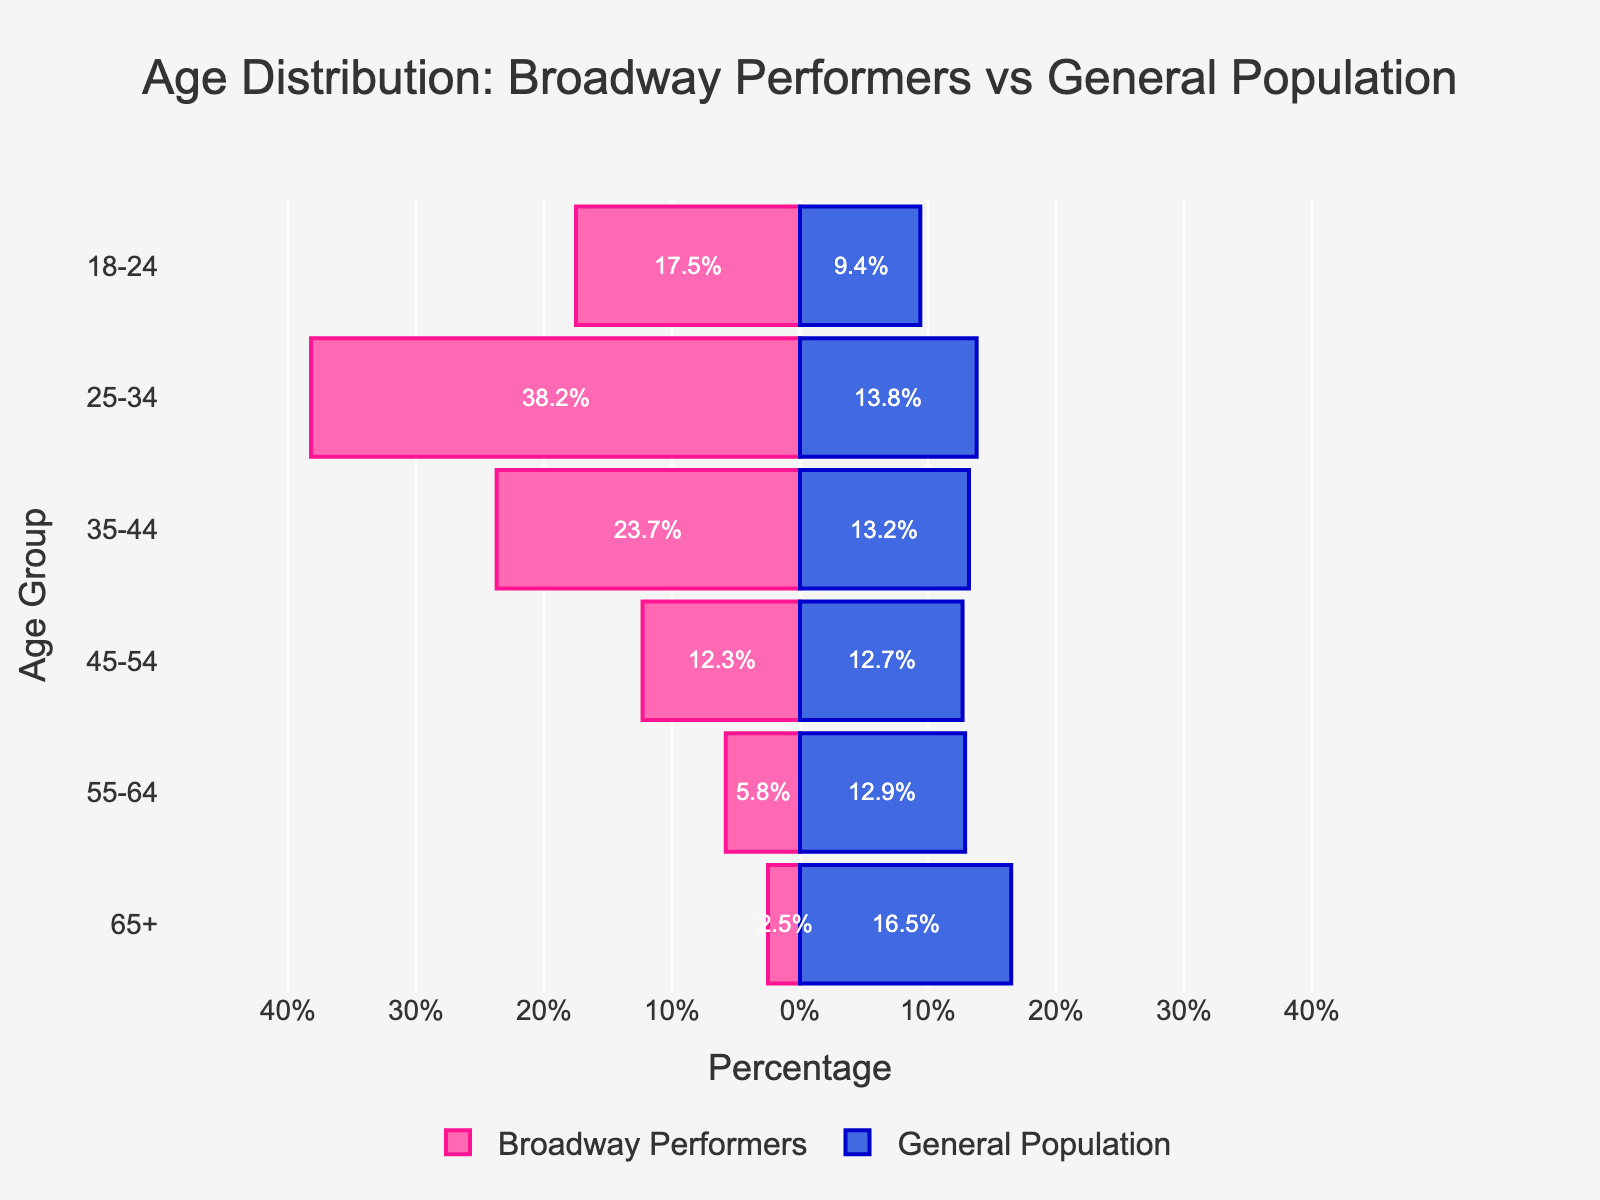What's the title of the figure? The title is positioned at the top of the figure. It often summarizes the main takeaway of the visualization. Here it states: 'Age Distribution: Broadway Performers vs General Population'.
Answer: Age Distribution: Broadway Performers vs General Population What age group has the highest percentage of Broadway Performers? By observing the bars on the left side of the pyramid, the highest bar corresponds to the age group '25-34'.
Answer: 25-34 Which age group in the general population has the highest percentage representation? Examining the bars on the right side, the tallest bar belongs to the '65+' age group.
Answer: 65+ How does the percentage of Broadway Performers in the 35-44 age group compare to the general population in the same age group? For Broadway Performers in the '35-44' group, the bar is at 23.7%. The bar for the general population in this group is 13.2%. The Broadway Performers percentage is higher.
Answer: It's higher What is the sum of percentages for the 18-24 and 25-34 age groups among Broadway Performers? The percentages for the age groups '18-24' and '25-34' are 17.5% and 38.2% respectively. Adding them gives 17.5 + 38.2 = 55.7%.
Answer: 55.7% How much larger is the percentage of the general population aged 65+ compared to Broadway Performers of the same age? The percentage for the general population aged 65+ is 16.5%, while for Broadway Performers it is 2.5%. The difference is 16.5 - 2.5 = 14%.
Answer: 14% Which population has a more uniform distribution across the age groups? By looking at the bars, the general population percentages are more evenly spread across age groups compared to Broadway Performers, who are heavily skewed toward younger ages.
Answer: General population What is the total percentage of Broadway Performers aged 45-64? Summing the values for '55-64' (5.8%) and '45-54' (12.3%) gives 5.8 + 12.3 = 18.1%.
Answer: 18.1% What’s the range of percentages on the x-axis in this figure? The x-axis ranges from -50% to 50%, shown as -40, -30, -20, -10, 0, 10, 20, 30, 40.
Answer: -50% to 50% Which age group shows the greatest disparity between Broadway Performers and the general population in percentage? The greatest disparity is observed in the '25-34' age group, where Broadway has 38.2% and the general population has 13.8%, leading to a difference of 24.4%.
Answer: 25-34 